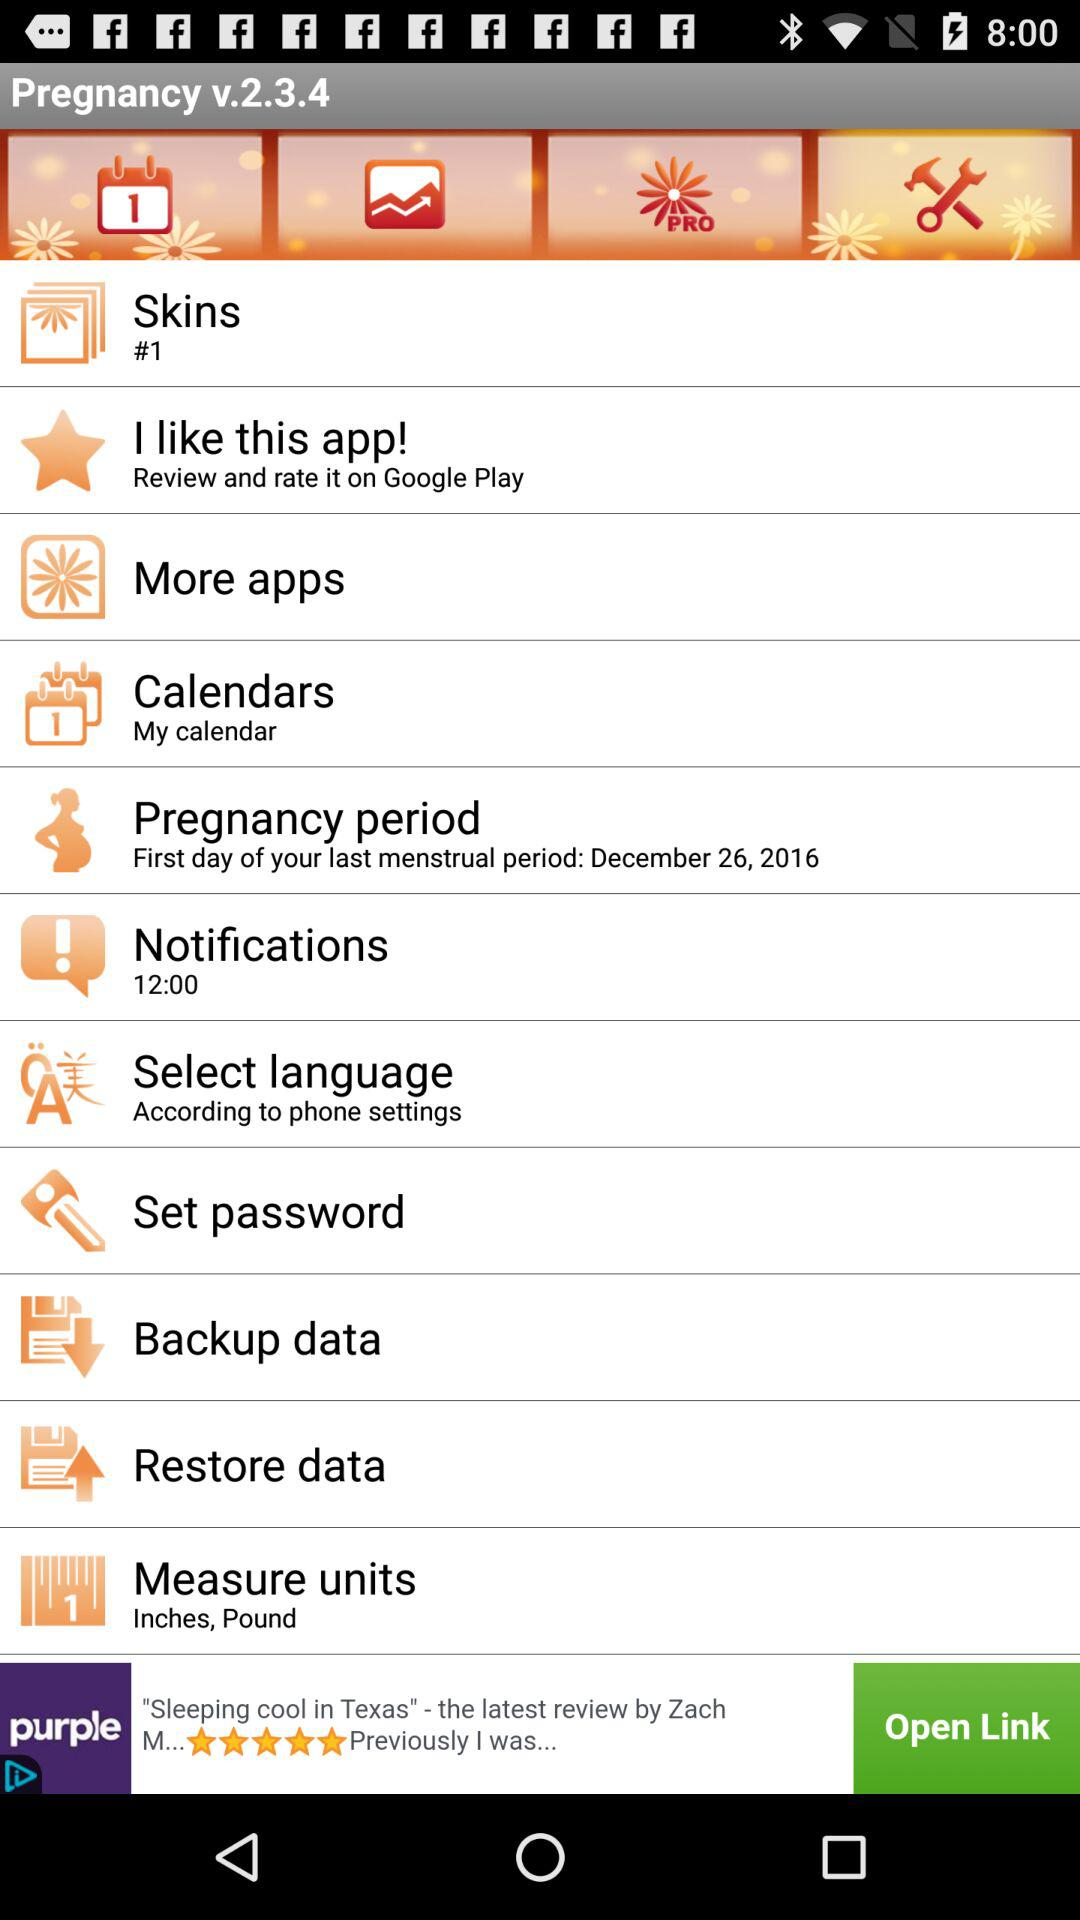What's the first day of the last menstrual period? The first day of the last menstrual period is December 26, 2016. 